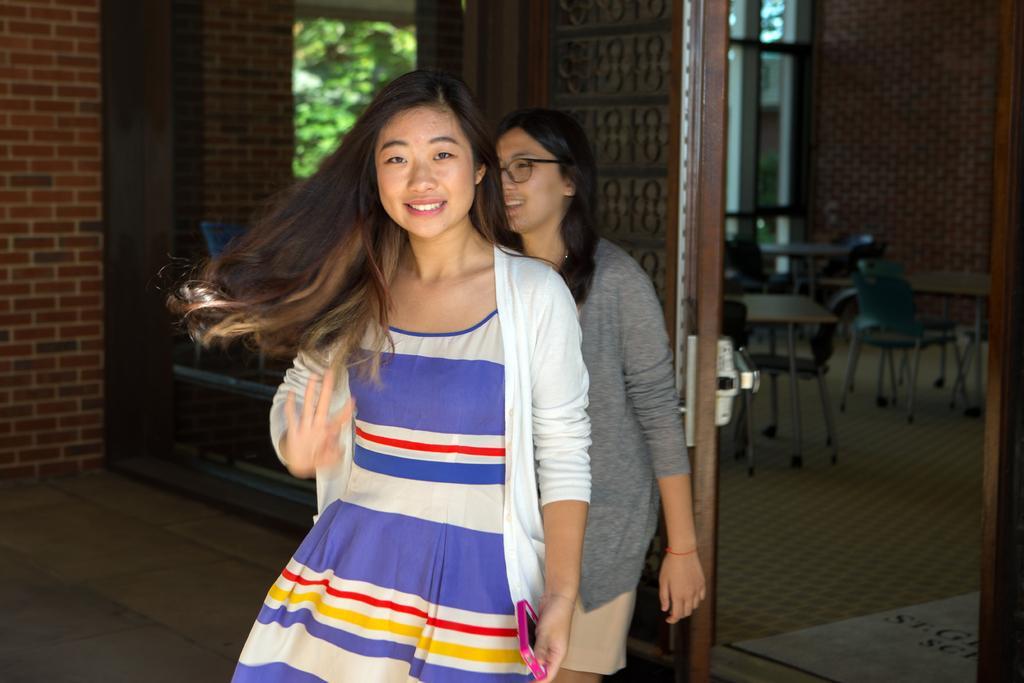Can you describe this image briefly? In the picture there is woman with long hair and background of her there is another woman,this seems to be clicked on the outside of a classroom. 